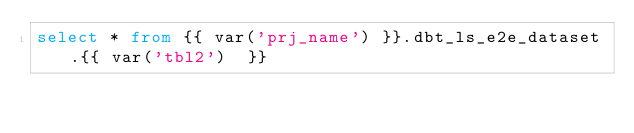Convert code to text. <code><loc_0><loc_0><loc_500><loc_500><_SQL_>select * from {{ var('prj_name') }}.dbt_ls_e2e_dataset.{{ var('tbl2')  }}
</code> 